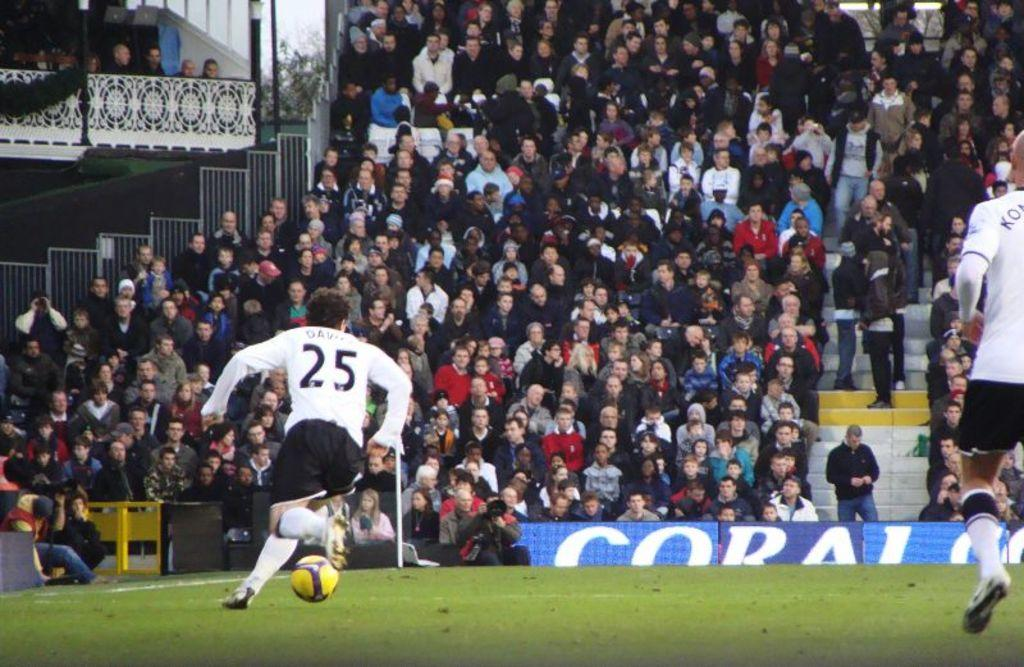<image>
Describe the image concisely. Number 25, Davis, dribbles the ball down the field. 